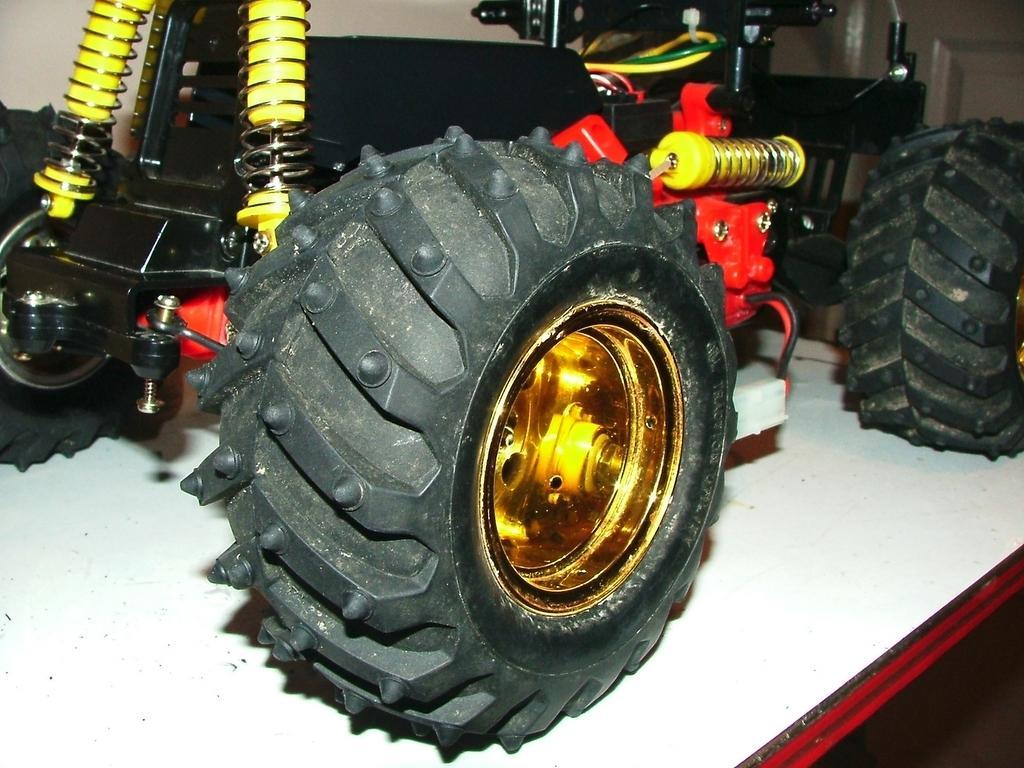What is the main subject of the image? The main subject of the image is a car. What are the wheels used for on the car? The wheels are used for the car to move on the ground. Where is the car located in the image? The car is placed on a table in the image. What can be seen in the top right corner of the image? There is a door in the top right corner of the image. What is visible at the top of the image? There is a wall at the top of the image. What type of underwear is hanging on the wall in the image? There is no underwear present in the image; only a car, table, door, and wall are visible. 